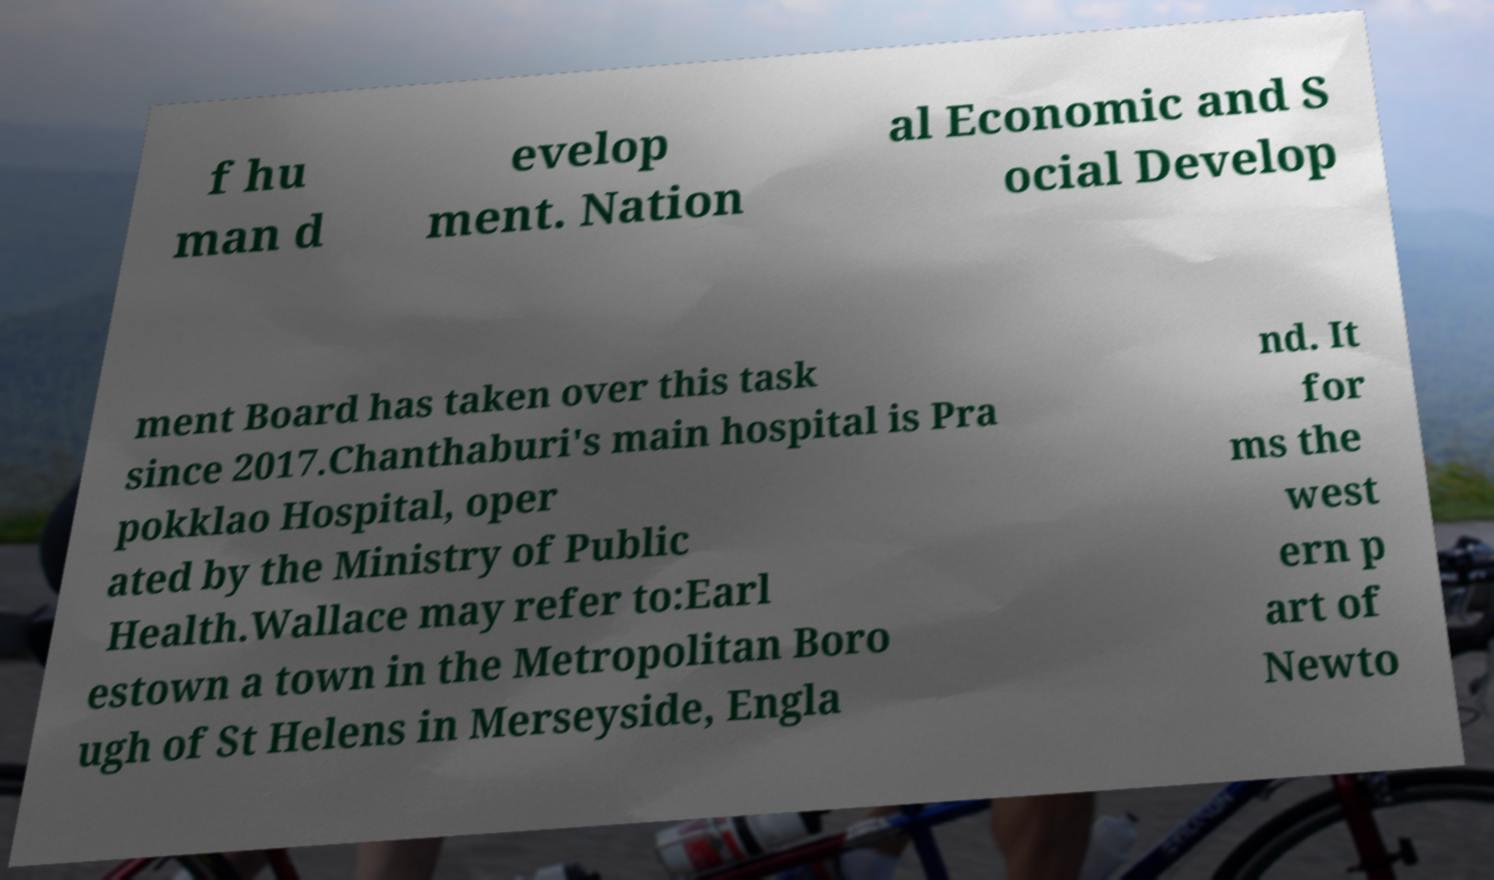Please read and relay the text visible in this image. What does it say? f hu man d evelop ment. Nation al Economic and S ocial Develop ment Board has taken over this task since 2017.Chanthaburi's main hospital is Pra pokklao Hospital, oper ated by the Ministry of Public Health.Wallace may refer to:Earl estown a town in the Metropolitan Boro ugh of St Helens in Merseyside, Engla nd. It for ms the west ern p art of Newto 